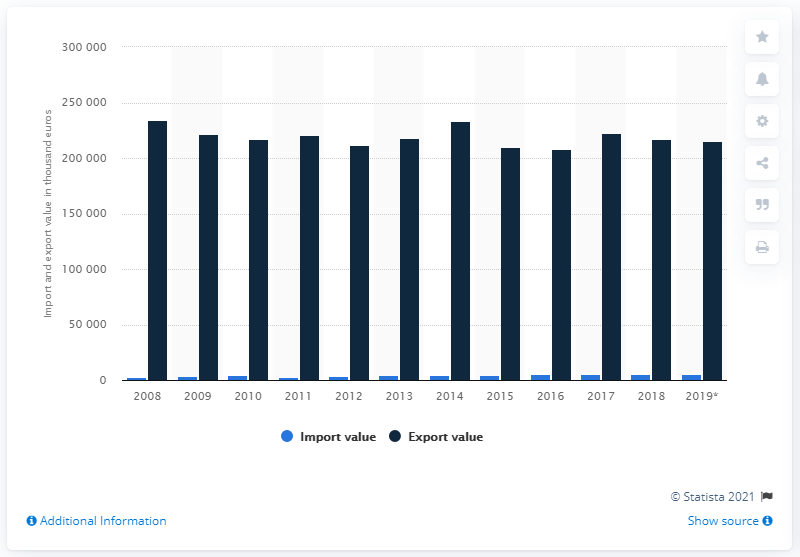Point out several critical features in this image. The value of tulip bulb exports in 2019 was 215,352. 